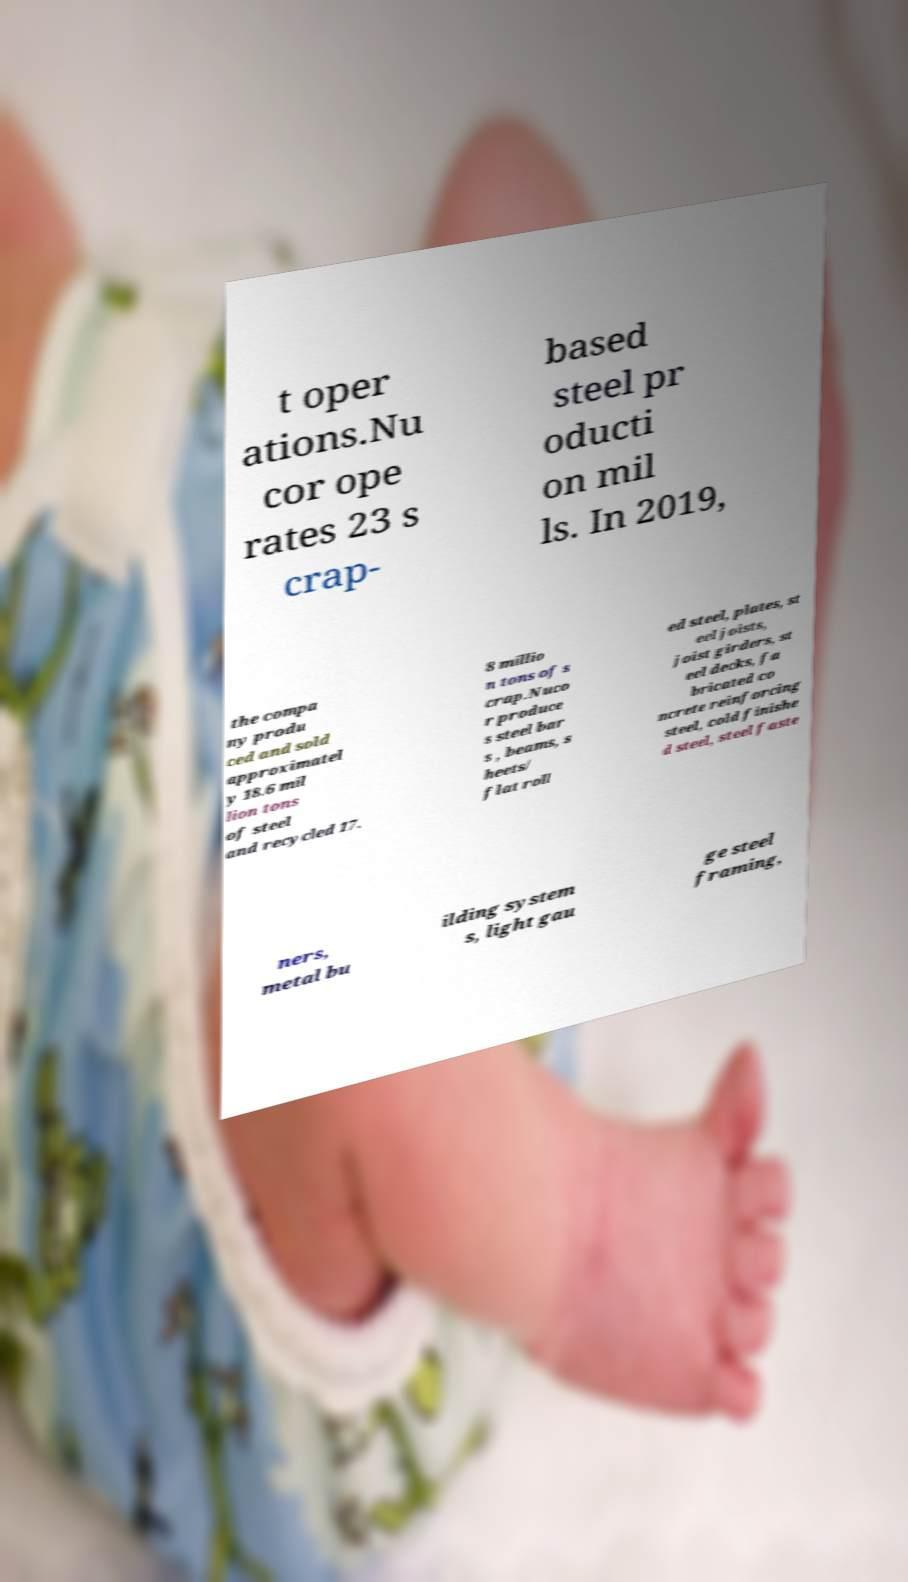There's text embedded in this image that I need extracted. Can you transcribe it verbatim? t oper ations.Nu cor ope rates 23 s crap- based steel pr oducti on mil ls. In 2019, the compa ny produ ced and sold approximatel y 18.6 mil lion tons of steel and recycled 17. 8 millio n tons of s crap.Nuco r produce s steel bar s , beams, s heets/ flat roll ed steel, plates, st eel joists, joist girders, st eel decks, fa bricated co ncrete reinforcing steel, cold finishe d steel, steel faste ners, metal bu ilding system s, light gau ge steel framing, 